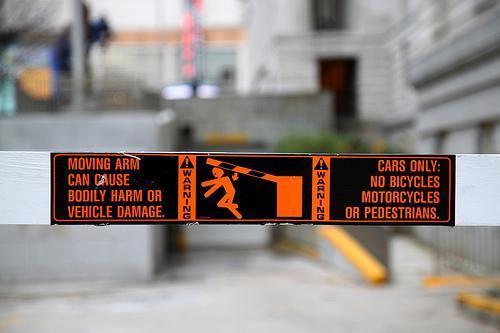How many boards are there?
Give a very brief answer. 1. 